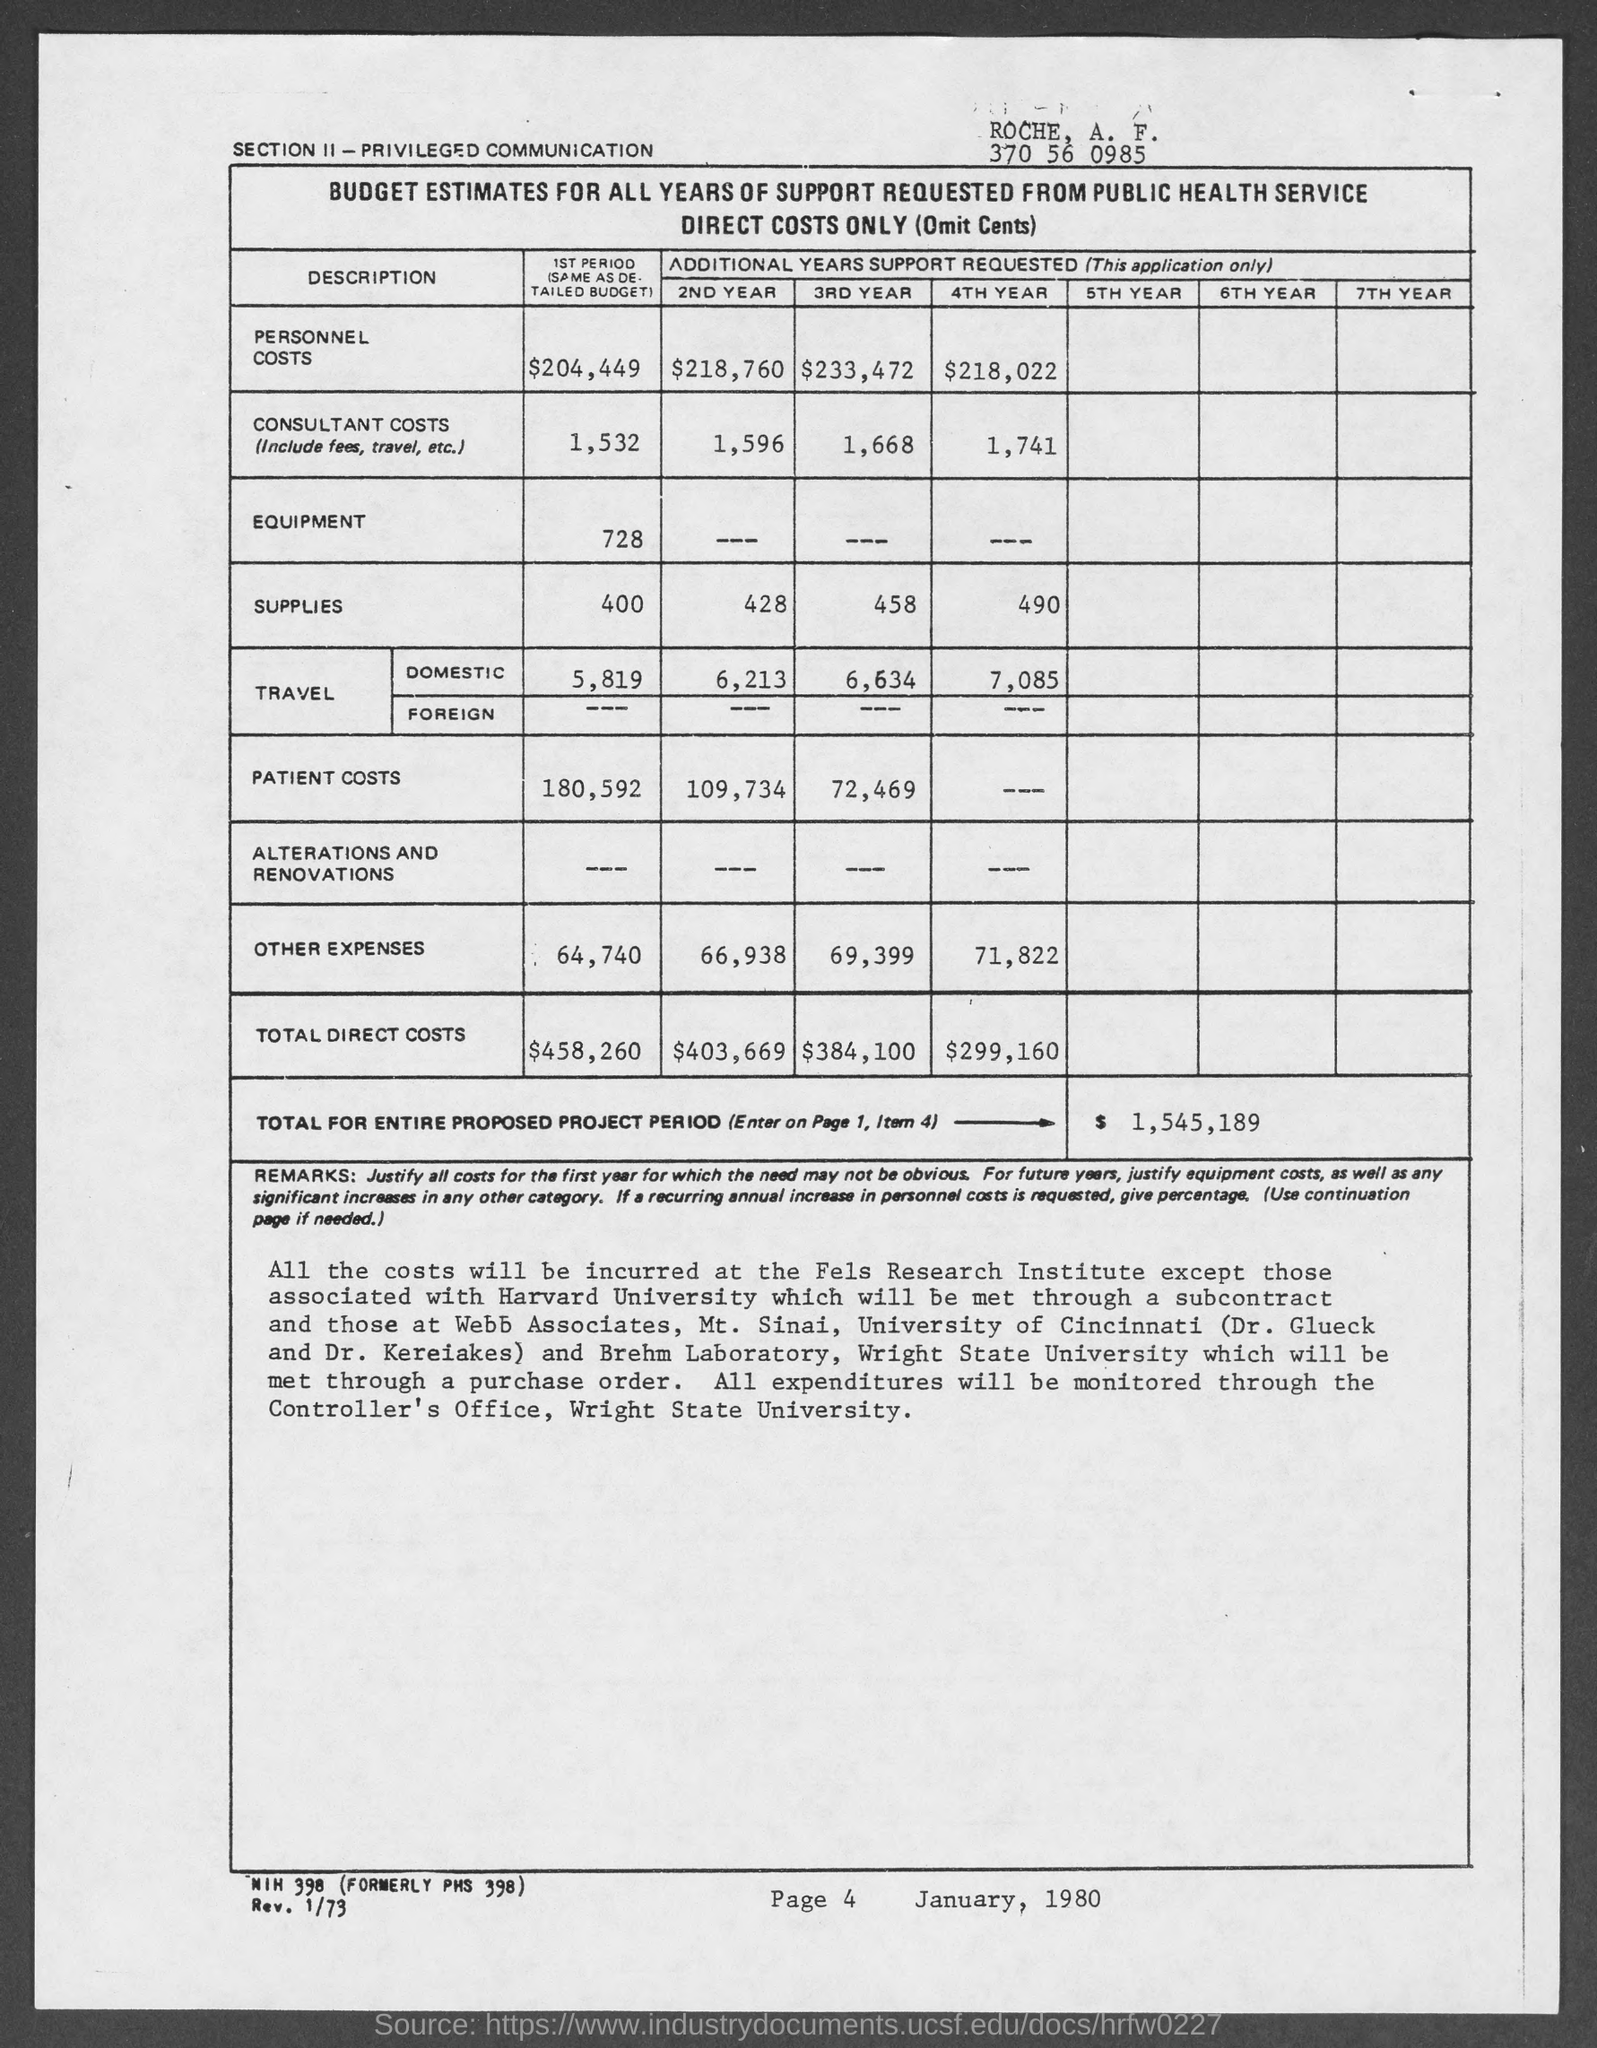Indicate a few pertinent items in this graphic. The total cost for the entire proposed project period is $1,545,189. 